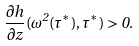<formula> <loc_0><loc_0><loc_500><loc_500>\frac { \partial h } { \partial z } ( \omega ^ { 2 } ( \tau ^ { * } ) , \tau ^ { * } ) > 0 .</formula> 